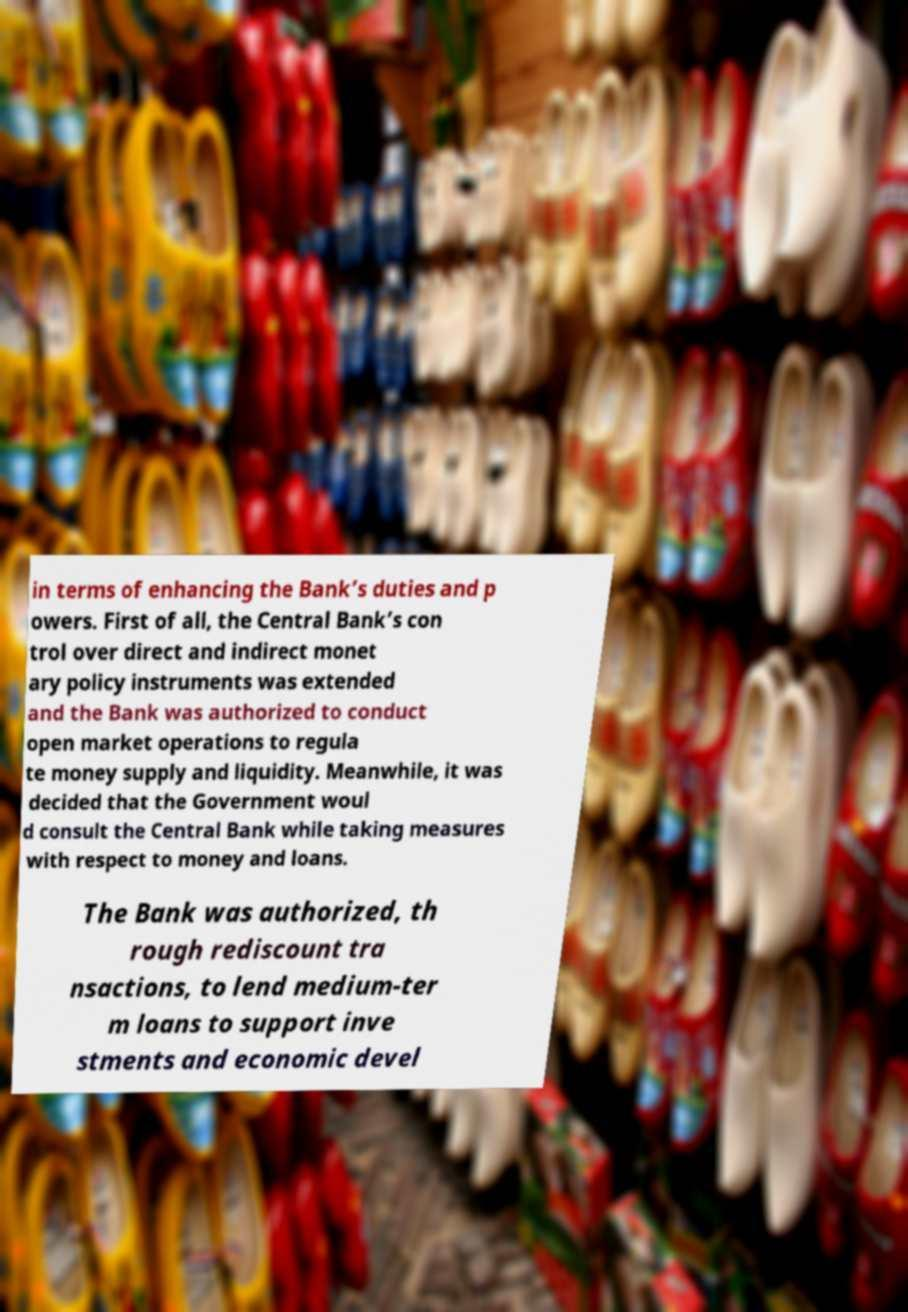Could you assist in decoding the text presented in this image and type it out clearly? in terms of enhancing the Bank’s duties and p owers. First of all, the Central Bank’s con trol over direct and indirect monet ary policy instruments was extended and the Bank was authorized to conduct open market operations to regula te money supply and liquidity. Meanwhile, it was decided that the Government woul d consult the Central Bank while taking measures with respect to money and loans. The Bank was authorized, th rough rediscount tra nsactions, to lend medium-ter m loans to support inve stments and economic devel 